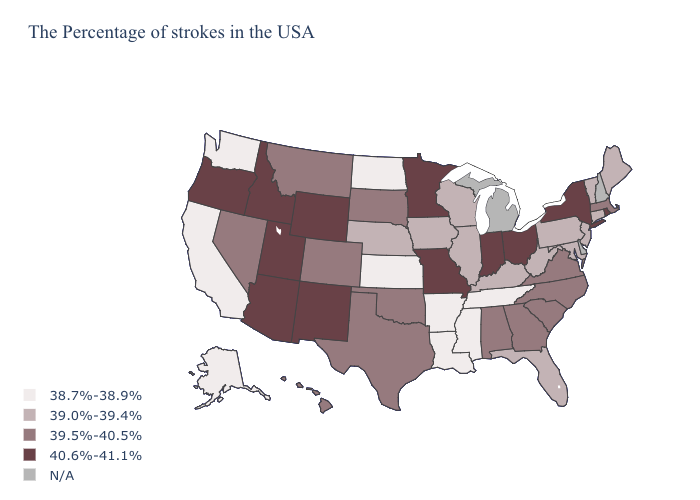What is the value of Indiana?
Quick response, please. 40.6%-41.1%. What is the value of California?
Be succinct. 38.7%-38.9%. Which states have the highest value in the USA?
Keep it brief. Rhode Island, New York, Ohio, Indiana, Missouri, Minnesota, Wyoming, New Mexico, Utah, Arizona, Idaho, Oregon. What is the lowest value in states that border Vermont?
Keep it brief. 39.5%-40.5%. Among the states that border Pennsylvania , which have the highest value?
Give a very brief answer. New York, Ohio. What is the highest value in states that border New Hampshire?
Answer briefly. 39.5%-40.5%. Does the first symbol in the legend represent the smallest category?
Answer briefly. Yes. Which states have the highest value in the USA?
Keep it brief. Rhode Island, New York, Ohio, Indiana, Missouri, Minnesota, Wyoming, New Mexico, Utah, Arizona, Idaho, Oregon. How many symbols are there in the legend?
Be succinct. 5. Name the states that have a value in the range 39.5%-40.5%?
Give a very brief answer. Massachusetts, Virginia, North Carolina, South Carolina, Georgia, Alabama, Oklahoma, Texas, South Dakota, Colorado, Montana, Nevada, Hawaii. Name the states that have a value in the range 39.0%-39.4%?
Short answer required. Maine, Vermont, Connecticut, New Jersey, Maryland, Pennsylvania, West Virginia, Florida, Kentucky, Wisconsin, Illinois, Iowa, Nebraska. What is the value of California?
Short answer required. 38.7%-38.9%. What is the value of Nevada?
Give a very brief answer. 39.5%-40.5%. Does Missouri have the highest value in the USA?
Answer briefly. Yes. Does New York have the highest value in the Northeast?
Quick response, please. Yes. 